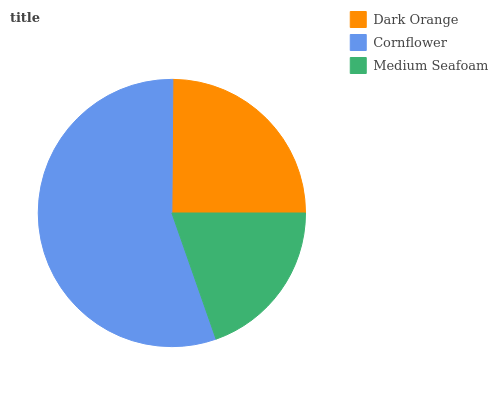Is Medium Seafoam the minimum?
Answer yes or no. Yes. Is Cornflower the maximum?
Answer yes or no. Yes. Is Cornflower the minimum?
Answer yes or no. No. Is Medium Seafoam the maximum?
Answer yes or no. No. Is Cornflower greater than Medium Seafoam?
Answer yes or no. Yes. Is Medium Seafoam less than Cornflower?
Answer yes or no. Yes. Is Medium Seafoam greater than Cornflower?
Answer yes or no. No. Is Cornflower less than Medium Seafoam?
Answer yes or no. No. Is Dark Orange the high median?
Answer yes or no. Yes. Is Dark Orange the low median?
Answer yes or no. Yes. Is Medium Seafoam the high median?
Answer yes or no. No. Is Medium Seafoam the low median?
Answer yes or no. No. 